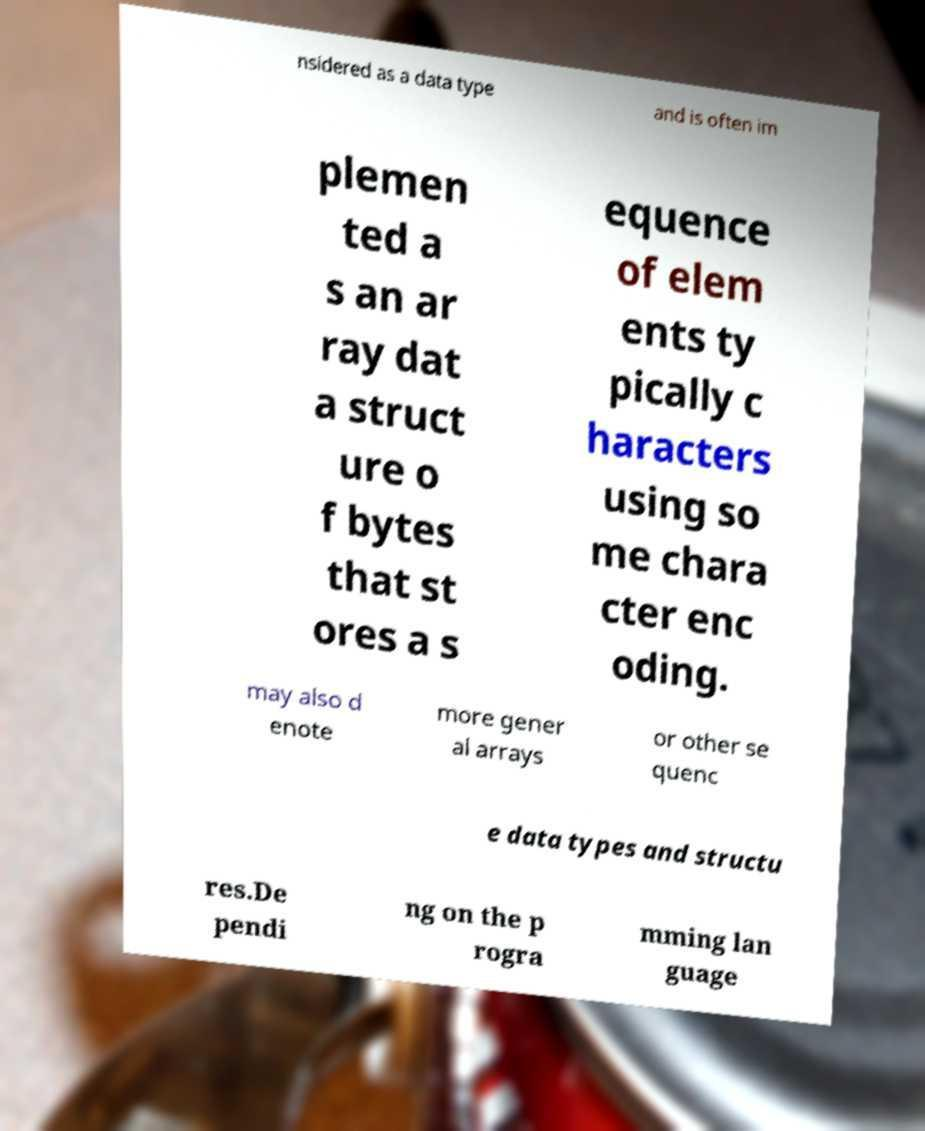Can you read and provide the text displayed in the image?This photo seems to have some interesting text. Can you extract and type it out for me? nsidered as a data type and is often im plemen ted a s an ar ray dat a struct ure o f bytes that st ores a s equence of elem ents ty pically c haracters using so me chara cter enc oding. may also d enote more gener al arrays or other se quenc e data types and structu res.De pendi ng on the p rogra mming lan guage 